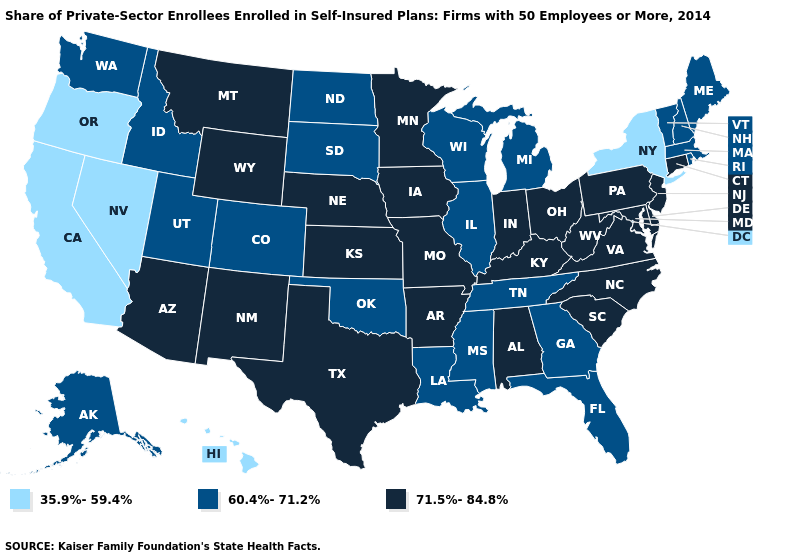Does New Jersey have the same value as Virginia?
Write a very short answer. Yes. What is the value of Kansas?
Concise answer only. 71.5%-84.8%. Which states have the highest value in the USA?
Answer briefly. Alabama, Arizona, Arkansas, Connecticut, Delaware, Indiana, Iowa, Kansas, Kentucky, Maryland, Minnesota, Missouri, Montana, Nebraska, New Jersey, New Mexico, North Carolina, Ohio, Pennsylvania, South Carolina, Texas, Virginia, West Virginia, Wyoming. What is the value of Illinois?
Concise answer only. 60.4%-71.2%. Does the first symbol in the legend represent the smallest category?
Give a very brief answer. Yes. Does South Dakota have the highest value in the MidWest?
Be succinct. No. Does the first symbol in the legend represent the smallest category?
Write a very short answer. Yes. What is the value of Missouri?
Answer briefly. 71.5%-84.8%. What is the highest value in the Northeast ?
Answer briefly. 71.5%-84.8%. What is the value of Colorado?
Give a very brief answer. 60.4%-71.2%. What is the value of Hawaii?
Quick response, please. 35.9%-59.4%. What is the lowest value in the South?
Keep it brief. 60.4%-71.2%. What is the value of Delaware?
Quick response, please. 71.5%-84.8%. Does Georgia have the same value as Wyoming?
Short answer required. No. 